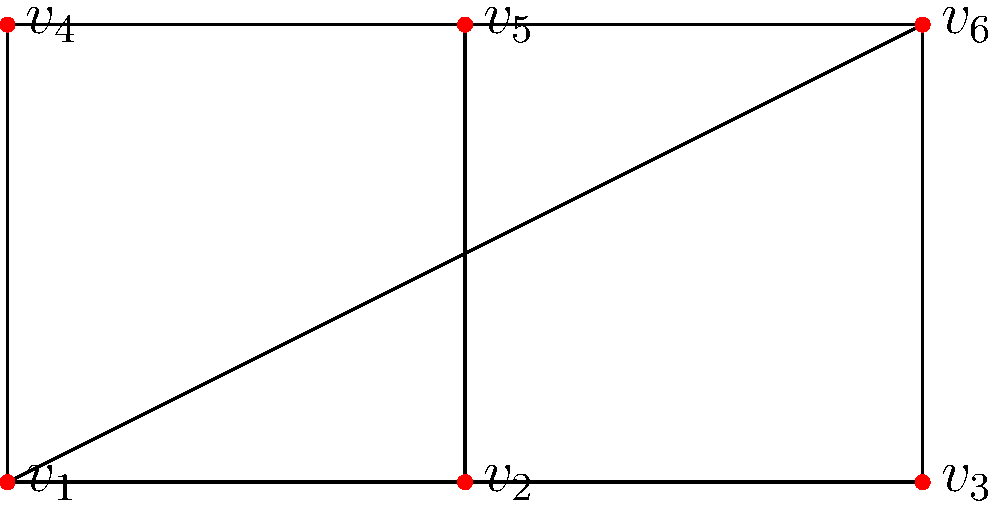As a retired Nigerian school principal, you're helping students prepare for a national topology competition. Consider the graph shown above. Is this graph planar? If so, provide a brief explanation of why. If not, identify which theorem it violates. To determine if the given graph is planar, we'll follow these steps:

1) First, let's count the number of vertices (V) and edges (E):
   V = 6 (vertices $v_1$ to $v_6$)
   E = 9 (count the number of lines in the diagram)

2) Recall Euler's formula for planar graphs: $V - E + F = 2$, where F is the number of faces.

3) If this graph is planar, we can solve for F:
   $6 - 9 + F = 2$
   $F = 5$

4) Now, let's check if this satisfies the inequality for a planar graph:
   $E \leq 3V - 6$ (for V ≥ 3)

5) Substituting our values:
   $9 \leq 3(6) - 6$
   $9 \leq 18 - 6$
   $9 \leq 12$

6) The inequality holds true, which means this graph satisfies the necessary condition for planarity.

7) Moreover, we can visually rearrange the graph to show it's planar:
   - Move $v_4$ inside the triangle formed by $v_1$, $v_2$, and $v_5$
   - The edge $v_1v_6$ can then be drawn without crossing any other edges

Therefore, this graph is indeed planar. It satisfies the necessary condition and can be drawn on a plane without any edge crossings.
Answer: Yes, the graph is planar. 